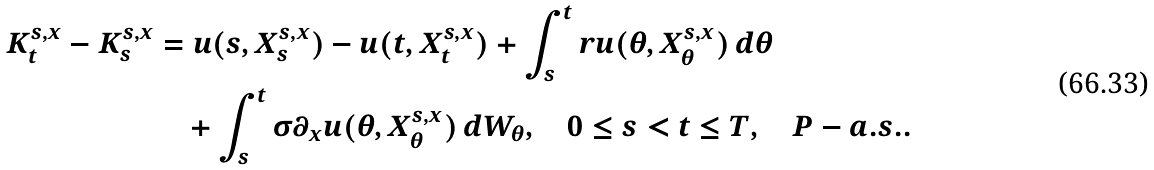Convert formula to latex. <formula><loc_0><loc_0><loc_500><loc_500>K ^ { s , x } _ { t } - K ^ { s , x } _ { s } & = u ( s , X ^ { s , x } _ { s } ) - u ( t , X ^ { s , x } _ { t } ) + \int ^ { t } _ { s } r u ( \theta , X ^ { s , x } _ { \theta } ) \, d \theta \\ & \quad + \int ^ { t } _ { s } \sigma \partial _ { x } u ( \theta , X ^ { s , x } _ { \theta } ) \, d W _ { \theta } , \quad 0 \leq s < t \leq T , \quad P - a . s . .</formula> 